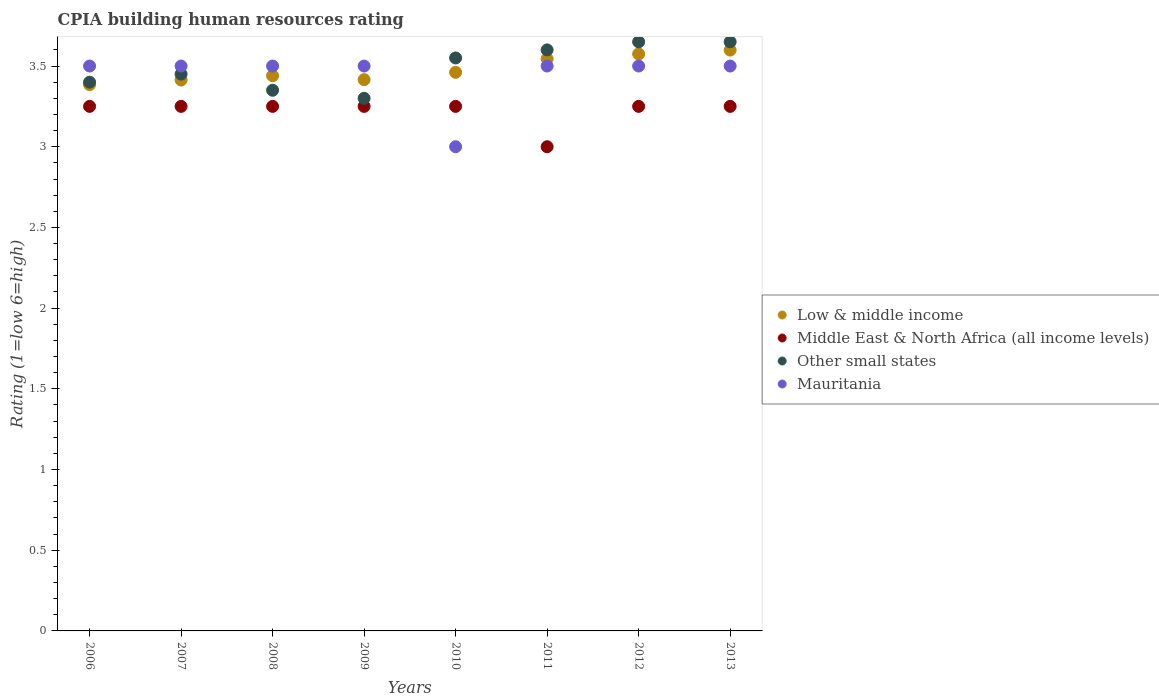What is the CPIA rating in Other small states in 2010?
Your answer should be very brief. 3.55. Across all years, what is the maximum CPIA rating in Low & middle income?
Offer a terse response. 3.6. Across all years, what is the minimum CPIA rating in Low & middle income?
Give a very brief answer. 3.38. In which year was the CPIA rating in Low & middle income minimum?
Provide a succinct answer. 2006. What is the total CPIA rating in Low & middle income in the graph?
Make the answer very short. 27.83. What is the difference between the CPIA rating in Other small states in 2006 and that in 2008?
Offer a very short reply. 0.05. What is the difference between the CPIA rating in Mauritania in 2011 and the CPIA rating in Low & middle income in 2010?
Offer a very short reply. 0.04. What is the average CPIA rating in Other small states per year?
Provide a succinct answer. 3.49. In the year 2006, what is the difference between the CPIA rating in Mauritania and CPIA rating in Low & middle income?
Ensure brevity in your answer.  0.12. In how many years, is the CPIA rating in Middle East & North Africa (all income levels) greater than 1.7?
Offer a very short reply. 8. What is the ratio of the CPIA rating in Mauritania in 2009 to that in 2010?
Your answer should be compact. 1.17. Is the CPIA rating in Low & middle income in 2008 less than that in 2009?
Ensure brevity in your answer.  No. Is the difference between the CPIA rating in Mauritania in 2009 and 2013 greater than the difference between the CPIA rating in Low & middle income in 2009 and 2013?
Your response must be concise. Yes. What is the difference between the highest and the second highest CPIA rating in Middle East & North Africa (all income levels)?
Keep it short and to the point. 0. What is the difference between the highest and the lowest CPIA rating in Other small states?
Ensure brevity in your answer.  0.35. Is the sum of the CPIA rating in Other small states in 2012 and 2013 greater than the maximum CPIA rating in Mauritania across all years?
Your answer should be compact. Yes. Is it the case that in every year, the sum of the CPIA rating in Middle East & North Africa (all income levels) and CPIA rating in Mauritania  is greater than the sum of CPIA rating in Low & middle income and CPIA rating in Other small states?
Offer a terse response. No. Does the CPIA rating in Mauritania monotonically increase over the years?
Make the answer very short. No. Is the CPIA rating in Low & middle income strictly greater than the CPIA rating in Other small states over the years?
Provide a succinct answer. No. How many dotlines are there?
Provide a short and direct response. 4. What is the difference between two consecutive major ticks on the Y-axis?
Your answer should be very brief. 0.5. Does the graph contain any zero values?
Keep it short and to the point. No. How many legend labels are there?
Your response must be concise. 4. How are the legend labels stacked?
Your response must be concise. Vertical. What is the title of the graph?
Your response must be concise. CPIA building human resources rating. What is the Rating (1=low 6=high) in Low & middle income in 2006?
Your response must be concise. 3.38. What is the Rating (1=low 6=high) of Mauritania in 2006?
Your answer should be compact. 3.5. What is the Rating (1=low 6=high) in Low & middle income in 2007?
Give a very brief answer. 3.41. What is the Rating (1=low 6=high) in Other small states in 2007?
Provide a succinct answer. 3.45. What is the Rating (1=low 6=high) of Low & middle income in 2008?
Give a very brief answer. 3.44. What is the Rating (1=low 6=high) of Middle East & North Africa (all income levels) in 2008?
Your response must be concise. 3.25. What is the Rating (1=low 6=high) in Other small states in 2008?
Keep it short and to the point. 3.35. What is the Rating (1=low 6=high) in Mauritania in 2008?
Make the answer very short. 3.5. What is the Rating (1=low 6=high) in Low & middle income in 2009?
Your answer should be compact. 3.42. What is the Rating (1=low 6=high) of Middle East & North Africa (all income levels) in 2009?
Your answer should be compact. 3.25. What is the Rating (1=low 6=high) in Other small states in 2009?
Your answer should be compact. 3.3. What is the Rating (1=low 6=high) in Low & middle income in 2010?
Offer a very short reply. 3.46. What is the Rating (1=low 6=high) in Middle East & North Africa (all income levels) in 2010?
Your answer should be very brief. 3.25. What is the Rating (1=low 6=high) in Other small states in 2010?
Provide a short and direct response. 3.55. What is the Rating (1=low 6=high) in Low & middle income in 2011?
Ensure brevity in your answer.  3.54. What is the Rating (1=low 6=high) in Low & middle income in 2012?
Provide a succinct answer. 3.58. What is the Rating (1=low 6=high) in Other small states in 2012?
Provide a short and direct response. 3.65. What is the Rating (1=low 6=high) in Mauritania in 2012?
Your response must be concise. 3.5. What is the Rating (1=low 6=high) in Low & middle income in 2013?
Offer a very short reply. 3.6. What is the Rating (1=low 6=high) of Other small states in 2013?
Your response must be concise. 3.65. Across all years, what is the maximum Rating (1=low 6=high) of Low & middle income?
Ensure brevity in your answer.  3.6. Across all years, what is the maximum Rating (1=low 6=high) in Other small states?
Give a very brief answer. 3.65. Across all years, what is the maximum Rating (1=low 6=high) of Mauritania?
Give a very brief answer. 3.5. Across all years, what is the minimum Rating (1=low 6=high) of Low & middle income?
Keep it short and to the point. 3.38. Across all years, what is the minimum Rating (1=low 6=high) in Middle East & North Africa (all income levels)?
Make the answer very short. 3. Across all years, what is the minimum Rating (1=low 6=high) of Other small states?
Keep it short and to the point. 3.3. What is the total Rating (1=low 6=high) in Low & middle income in the graph?
Ensure brevity in your answer.  27.83. What is the total Rating (1=low 6=high) in Middle East & North Africa (all income levels) in the graph?
Your answer should be compact. 25.75. What is the total Rating (1=low 6=high) in Other small states in the graph?
Your answer should be very brief. 27.95. What is the difference between the Rating (1=low 6=high) of Low & middle income in 2006 and that in 2007?
Provide a short and direct response. -0.03. What is the difference between the Rating (1=low 6=high) in Middle East & North Africa (all income levels) in 2006 and that in 2007?
Provide a succinct answer. 0. What is the difference between the Rating (1=low 6=high) in Low & middle income in 2006 and that in 2008?
Make the answer very short. -0.06. What is the difference between the Rating (1=low 6=high) in Other small states in 2006 and that in 2008?
Offer a terse response. 0.05. What is the difference between the Rating (1=low 6=high) in Low & middle income in 2006 and that in 2009?
Provide a succinct answer. -0.03. What is the difference between the Rating (1=low 6=high) in Other small states in 2006 and that in 2009?
Offer a terse response. 0.1. What is the difference between the Rating (1=low 6=high) of Mauritania in 2006 and that in 2009?
Your response must be concise. 0. What is the difference between the Rating (1=low 6=high) of Low & middle income in 2006 and that in 2010?
Your response must be concise. -0.08. What is the difference between the Rating (1=low 6=high) in Middle East & North Africa (all income levels) in 2006 and that in 2010?
Keep it short and to the point. 0. What is the difference between the Rating (1=low 6=high) in Mauritania in 2006 and that in 2010?
Give a very brief answer. 0.5. What is the difference between the Rating (1=low 6=high) of Low & middle income in 2006 and that in 2011?
Offer a terse response. -0.16. What is the difference between the Rating (1=low 6=high) in Other small states in 2006 and that in 2011?
Your answer should be compact. -0.2. What is the difference between the Rating (1=low 6=high) in Low & middle income in 2006 and that in 2012?
Offer a terse response. -0.19. What is the difference between the Rating (1=low 6=high) in Other small states in 2006 and that in 2012?
Provide a short and direct response. -0.25. What is the difference between the Rating (1=low 6=high) in Mauritania in 2006 and that in 2012?
Your answer should be compact. 0. What is the difference between the Rating (1=low 6=high) of Low & middle income in 2006 and that in 2013?
Keep it short and to the point. -0.21. What is the difference between the Rating (1=low 6=high) in Other small states in 2006 and that in 2013?
Provide a short and direct response. -0.25. What is the difference between the Rating (1=low 6=high) of Low & middle income in 2007 and that in 2008?
Give a very brief answer. -0.03. What is the difference between the Rating (1=low 6=high) in Low & middle income in 2007 and that in 2009?
Provide a succinct answer. -0. What is the difference between the Rating (1=low 6=high) of Middle East & North Africa (all income levels) in 2007 and that in 2009?
Your response must be concise. 0. What is the difference between the Rating (1=low 6=high) in Low & middle income in 2007 and that in 2010?
Your answer should be compact. -0.05. What is the difference between the Rating (1=low 6=high) in Mauritania in 2007 and that in 2010?
Offer a terse response. 0.5. What is the difference between the Rating (1=low 6=high) of Low & middle income in 2007 and that in 2011?
Offer a terse response. -0.13. What is the difference between the Rating (1=low 6=high) in Middle East & North Africa (all income levels) in 2007 and that in 2011?
Provide a short and direct response. 0.25. What is the difference between the Rating (1=low 6=high) in Other small states in 2007 and that in 2011?
Provide a short and direct response. -0.15. What is the difference between the Rating (1=low 6=high) in Low & middle income in 2007 and that in 2012?
Provide a succinct answer. -0.16. What is the difference between the Rating (1=low 6=high) in Middle East & North Africa (all income levels) in 2007 and that in 2012?
Your answer should be very brief. 0. What is the difference between the Rating (1=low 6=high) in Low & middle income in 2007 and that in 2013?
Ensure brevity in your answer.  -0.19. What is the difference between the Rating (1=low 6=high) of Low & middle income in 2008 and that in 2009?
Offer a terse response. 0.02. What is the difference between the Rating (1=low 6=high) in Middle East & North Africa (all income levels) in 2008 and that in 2009?
Offer a very short reply. 0. What is the difference between the Rating (1=low 6=high) of Other small states in 2008 and that in 2009?
Provide a short and direct response. 0.05. What is the difference between the Rating (1=low 6=high) of Low & middle income in 2008 and that in 2010?
Offer a very short reply. -0.02. What is the difference between the Rating (1=low 6=high) of Middle East & North Africa (all income levels) in 2008 and that in 2010?
Make the answer very short. 0. What is the difference between the Rating (1=low 6=high) in Mauritania in 2008 and that in 2010?
Provide a short and direct response. 0.5. What is the difference between the Rating (1=low 6=high) of Low & middle income in 2008 and that in 2011?
Your response must be concise. -0.1. What is the difference between the Rating (1=low 6=high) in Middle East & North Africa (all income levels) in 2008 and that in 2011?
Ensure brevity in your answer.  0.25. What is the difference between the Rating (1=low 6=high) of Mauritania in 2008 and that in 2011?
Offer a terse response. 0. What is the difference between the Rating (1=low 6=high) of Low & middle income in 2008 and that in 2012?
Provide a succinct answer. -0.14. What is the difference between the Rating (1=low 6=high) in Middle East & North Africa (all income levels) in 2008 and that in 2012?
Your answer should be very brief. 0. What is the difference between the Rating (1=low 6=high) in Other small states in 2008 and that in 2012?
Give a very brief answer. -0.3. What is the difference between the Rating (1=low 6=high) in Mauritania in 2008 and that in 2012?
Give a very brief answer. 0. What is the difference between the Rating (1=low 6=high) in Low & middle income in 2008 and that in 2013?
Your answer should be compact. -0.16. What is the difference between the Rating (1=low 6=high) in Middle East & North Africa (all income levels) in 2008 and that in 2013?
Ensure brevity in your answer.  0. What is the difference between the Rating (1=low 6=high) of Low & middle income in 2009 and that in 2010?
Provide a short and direct response. -0.05. What is the difference between the Rating (1=low 6=high) in Middle East & North Africa (all income levels) in 2009 and that in 2010?
Ensure brevity in your answer.  0. What is the difference between the Rating (1=low 6=high) of Other small states in 2009 and that in 2010?
Keep it short and to the point. -0.25. What is the difference between the Rating (1=low 6=high) of Mauritania in 2009 and that in 2010?
Give a very brief answer. 0.5. What is the difference between the Rating (1=low 6=high) of Low & middle income in 2009 and that in 2011?
Ensure brevity in your answer.  -0.13. What is the difference between the Rating (1=low 6=high) in Middle East & North Africa (all income levels) in 2009 and that in 2011?
Offer a terse response. 0.25. What is the difference between the Rating (1=low 6=high) in Other small states in 2009 and that in 2011?
Your answer should be compact. -0.3. What is the difference between the Rating (1=low 6=high) in Low & middle income in 2009 and that in 2012?
Offer a very short reply. -0.16. What is the difference between the Rating (1=low 6=high) of Middle East & North Africa (all income levels) in 2009 and that in 2012?
Your answer should be very brief. 0. What is the difference between the Rating (1=low 6=high) in Other small states in 2009 and that in 2012?
Provide a short and direct response. -0.35. What is the difference between the Rating (1=low 6=high) in Mauritania in 2009 and that in 2012?
Ensure brevity in your answer.  0. What is the difference between the Rating (1=low 6=high) of Low & middle income in 2009 and that in 2013?
Make the answer very short. -0.18. What is the difference between the Rating (1=low 6=high) of Other small states in 2009 and that in 2013?
Provide a succinct answer. -0.35. What is the difference between the Rating (1=low 6=high) of Low & middle income in 2010 and that in 2011?
Offer a very short reply. -0.08. What is the difference between the Rating (1=low 6=high) in Low & middle income in 2010 and that in 2012?
Your response must be concise. -0.11. What is the difference between the Rating (1=low 6=high) of Middle East & North Africa (all income levels) in 2010 and that in 2012?
Provide a succinct answer. 0. What is the difference between the Rating (1=low 6=high) in Other small states in 2010 and that in 2012?
Provide a succinct answer. -0.1. What is the difference between the Rating (1=low 6=high) in Low & middle income in 2010 and that in 2013?
Your response must be concise. -0.14. What is the difference between the Rating (1=low 6=high) of Other small states in 2010 and that in 2013?
Make the answer very short. -0.1. What is the difference between the Rating (1=low 6=high) of Mauritania in 2010 and that in 2013?
Your response must be concise. -0.5. What is the difference between the Rating (1=low 6=high) in Low & middle income in 2011 and that in 2012?
Offer a terse response. -0.03. What is the difference between the Rating (1=low 6=high) in Other small states in 2011 and that in 2012?
Your answer should be very brief. -0.05. What is the difference between the Rating (1=low 6=high) in Mauritania in 2011 and that in 2012?
Offer a terse response. 0. What is the difference between the Rating (1=low 6=high) in Low & middle income in 2011 and that in 2013?
Keep it short and to the point. -0.05. What is the difference between the Rating (1=low 6=high) in Mauritania in 2011 and that in 2013?
Provide a short and direct response. 0. What is the difference between the Rating (1=low 6=high) of Low & middle income in 2012 and that in 2013?
Provide a succinct answer. -0.02. What is the difference between the Rating (1=low 6=high) in Other small states in 2012 and that in 2013?
Provide a succinct answer. 0. What is the difference between the Rating (1=low 6=high) in Mauritania in 2012 and that in 2013?
Provide a succinct answer. 0. What is the difference between the Rating (1=low 6=high) of Low & middle income in 2006 and the Rating (1=low 6=high) of Middle East & North Africa (all income levels) in 2007?
Keep it short and to the point. 0.13. What is the difference between the Rating (1=low 6=high) in Low & middle income in 2006 and the Rating (1=low 6=high) in Other small states in 2007?
Offer a terse response. -0.07. What is the difference between the Rating (1=low 6=high) of Low & middle income in 2006 and the Rating (1=low 6=high) of Mauritania in 2007?
Offer a very short reply. -0.12. What is the difference between the Rating (1=low 6=high) in Middle East & North Africa (all income levels) in 2006 and the Rating (1=low 6=high) in Other small states in 2007?
Provide a short and direct response. -0.2. What is the difference between the Rating (1=low 6=high) of Low & middle income in 2006 and the Rating (1=low 6=high) of Middle East & North Africa (all income levels) in 2008?
Provide a short and direct response. 0.13. What is the difference between the Rating (1=low 6=high) of Low & middle income in 2006 and the Rating (1=low 6=high) of Other small states in 2008?
Provide a succinct answer. 0.03. What is the difference between the Rating (1=low 6=high) in Low & middle income in 2006 and the Rating (1=low 6=high) in Mauritania in 2008?
Keep it short and to the point. -0.12. What is the difference between the Rating (1=low 6=high) of Middle East & North Africa (all income levels) in 2006 and the Rating (1=low 6=high) of Other small states in 2008?
Ensure brevity in your answer.  -0.1. What is the difference between the Rating (1=low 6=high) in Other small states in 2006 and the Rating (1=low 6=high) in Mauritania in 2008?
Provide a succinct answer. -0.1. What is the difference between the Rating (1=low 6=high) of Low & middle income in 2006 and the Rating (1=low 6=high) of Middle East & North Africa (all income levels) in 2009?
Your answer should be compact. 0.13. What is the difference between the Rating (1=low 6=high) of Low & middle income in 2006 and the Rating (1=low 6=high) of Other small states in 2009?
Give a very brief answer. 0.08. What is the difference between the Rating (1=low 6=high) in Low & middle income in 2006 and the Rating (1=low 6=high) in Mauritania in 2009?
Keep it short and to the point. -0.12. What is the difference between the Rating (1=low 6=high) in Other small states in 2006 and the Rating (1=low 6=high) in Mauritania in 2009?
Your answer should be compact. -0.1. What is the difference between the Rating (1=low 6=high) in Low & middle income in 2006 and the Rating (1=low 6=high) in Middle East & North Africa (all income levels) in 2010?
Offer a very short reply. 0.13. What is the difference between the Rating (1=low 6=high) of Low & middle income in 2006 and the Rating (1=low 6=high) of Other small states in 2010?
Your response must be concise. -0.17. What is the difference between the Rating (1=low 6=high) of Low & middle income in 2006 and the Rating (1=low 6=high) of Mauritania in 2010?
Your answer should be compact. 0.38. What is the difference between the Rating (1=low 6=high) in Middle East & North Africa (all income levels) in 2006 and the Rating (1=low 6=high) in Other small states in 2010?
Keep it short and to the point. -0.3. What is the difference between the Rating (1=low 6=high) in Other small states in 2006 and the Rating (1=low 6=high) in Mauritania in 2010?
Make the answer very short. 0.4. What is the difference between the Rating (1=low 6=high) of Low & middle income in 2006 and the Rating (1=low 6=high) of Middle East & North Africa (all income levels) in 2011?
Provide a short and direct response. 0.38. What is the difference between the Rating (1=low 6=high) in Low & middle income in 2006 and the Rating (1=low 6=high) in Other small states in 2011?
Provide a short and direct response. -0.22. What is the difference between the Rating (1=low 6=high) in Low & middle income in 2006 and the Rating (1=low 6=high) in Mauritania in 2011?
Provide a short and direct response. -0.12. What is the difference between the Rating (1=low 6=high) in Middle East & North Africa (all income levels) in 2006 and the Rating (1=low 6=high) in Other small states in 2011?
Provide a succinct answer. -0.35. What is the difference between the Rating (1=low 6=high) of Middle East & North Africa (all income levels) in 2006 and the Rating (1=low 6=high) of Mauritania in 2011?
Provide a short and direct response. -0.25. What is the difference between the Rating (1=low 6=high) in Low & middle income in 2006 and the Rating (1=low 6=high) in Middle East & North Africa (all income levels) in 2012?
Give a very brief answer. 0.13. What is the difference between the Rating (1=low 6=high) of Low & middle income in 2006 and the Rating (1=low 6=high) of Other small states in 2012?
Your answer should be compact. -0.27. What is the difference between the Rating (1=low 6=high) of Low & middle income in 2006 and the Rating (1=low 6=high) of Mauritania in 2012?
Offer a very short reply. -0.12. What is the difference between the Rating (1=low 6=high) of Other small states in 2006 and the Rating (1=low 6=high) of Mauritania in 2012?
Your response must be concise. -0.1. What is the difference between the Rating (1=low 6=high) of Low & middle income in 2006 and the Rating (1=low 6=high) of Middle East & North Africa (all income levels) in 2013?
Provide a succinct answer. 0.13. What is the difference between the Rating (1=low 6=high) of Low & middle income in 2006 and the Rating (1=low 6=high) of Other small states in 2013?
Ensure brevity in your answer.  -0.27. What is the difference between the Rating (1=low 6=high) of Low & middle income in 2006 and the Rating (1=low 6=high) of Mauritania in 2013?
Keep it short and to the point. -0.12. What is the difference between the Rating (1=low 6=high) in Low & middle income in 2007 and the Rating (1=low 6=high) in Middle East & North Africa (all income levels) in 2008?
Make the answer very short. 0.16. What is the difference between the Rating (1=low 6=high) of Low & middle income in 2007 and the Rating (1=low 6=high) of Other small states in 2008?
Keep it short and to the point. 0.06. What is the difference between the Rating (1=low 6=high) of Low & middle income in 2007 and the Rating (1=low 6=high) of Mauritania in 2008?
Your response must be concise. -0.09. What is the difference between the Rating (1=low 6=high) of Other small states in 2007 and the Rating (1=low 6=high) of Mauritania in 2008?
Provide a short and direct response. -0.05. What is the difference between the Rating (1=low 6=high) in Low & middle income in 2007 and the Rating (1=low 6=high) in Middle East & North Africa (all income levels) in 2009?
Your answer should be compact. 0.16. What is the difference between the Rating (1=low 6=high) of Low & middle income in 2007 and the Rating (1=low 6=high) of Other small states in 2009?
Ensure brevity in your answer.  0.11. What is the difference between the Rating (1=low 6=high) of Low & middle income in 2007 and the Rating (1=low 6=high) of Mauritania in 2009?
Make the answer very short. -0.09. What is the difference between the Rating (1=low 6=high) in Middle East & North Africa (all income levels) in 2007 and the Rating (1=low 6=high) in Other small states in 2009?
Make the answer very short. -0.05. What is the difference between the Rating (1=low 6=high) in Low & middle income in 2007 and the Rating (1=low 6=high) in Middle East & North Africa (all income levels) in 2010?
Provide a short and direct response. 0.16. What is the difference between the Rating (1=low 6=high) of Low & middle income in 2007 and the Rating (1=low 6=high) of Other small states in 2010?
Your answer should be compact. -0.14. What is the difference between the Rating (1=low 6=high) of Low & middle income in 2007 and the Rating (1=low 6=high) of Mauritania in 2010?
Your answer should be compact. 0.41. What is the difference between the Rating (1=low 6=high) in Other small states in 2007 and the Rating (1=low 6=high) in Mauritania in 2010?
Offer a very short reply. 0.45. What is the difference between the Rating (1=low 6=high) in Low & middle income in 2007 and the Rating (1=low 6=high) in Middle East & North Africa (all income levels) in 2011?
Keep it short and to the point. 0.41. What is the difference between the Rating (1=low 6=high) in Low & middle income in 2007 and the Rating (1=low 6=high) in Other small states in 2011?
Make the answer very short. -0.19. What is the difference between the Rating (1=low 6=high) in Low & middle income in 2007 and the Rating (1=low 6=high) in Mauritania in 2011?
Provide a short and direct response. -0.09. What is the difference between the Rating (1=low 6=high) in Middle East & North Africa (all income levels) in 2007 and the Rating (1=low 6=high) in Other small states in 2011?
Offer a very short reply. -0.35. What is the difference between the Rating (1=low 6=high) of Other small states in 2007 and the Rating (1=low 6=high) of Mauritania in 2011?
Provide a short and direct response. -0.05. What is the difference between the Rating (1=low 6=high) of Low & middle income in 2007 and the Rating (1=low 6=high) of Middle East & North Africa (all income levels) in 2012?
Your answer should be very brief. 0.16. What is the difference between the Rating (1=low 6=high) in Low & middle income in 2007 and the Rating (1=low 6=high) in Other small states in 2012?
Ensure brevity in your answer.  -0.24. What is the difference between the Rating (1=low 6=high) of Low & middle income in 2007 and the Rating (1=low 6=high) of Mauritania in 2012?
Your answer should be very brief. -0.09. What is the difference between the Rating (1=low 6=high) in Middle East & North Africa (all income levels) in 2007 and the Rating (1=low 6=high) in Other small states in 2012?
Your response must be concise. -0.4. What is the difference between the Rating (1=low 6=high) in Other small states in 2007 and the Rating (1=low 6=high) in Mauritania in 2012?
Ensure brevity in your answer.  -0.05. What is the difference between the Rating (1=low 6=high) of Low & middle income in 2007 and the Rating (1=low 6=high) of Middle East & North Africa (all income levels) in 2013?
Your response must be concise. 0.16. What is the difference between the Rating (1=low 6=high) of Low & middle income in 2007 and the Rating (1=low 6=high) of Other small states in 2013?
Make the answer very short. -0.24. What is the difference between the Rating (1=low 6=high) of Low & middle income in 2007 and the Rating (1=low 6=high) of Mauritania in 2013?
Your answer should be compact. -0.09. What is the difference between the Rating (1=low 6=high) of Middle East & North Africa (all income levels) in 2007 and the Rating (1=low 6=high) of Other small states in 2013?
Provide a short and direct response. -0.4. What is the difference between the Rating (1=low 6=high) in Middle East & North Africa (all income levels) in 2007 and the Rating (1=low 6=high) in Mauritania in 2013?
Offer a terse response. -0.25. What is the difference between the Rating (1=low 6=high) of Other small states in 2007 and the Rating (1=low 6=high) of Mauritania in 2013?
Provide a short and direct response. -0.05. What is the difference between the Rating (1=low 6=high) of Low & middle income in 2008 and the Rating (1=low 6=high) of Middle East & North Africa (all income levels) in 2009?
Your answer should be compact. 0.19. What is the difference between the Rating (1=low 6=high) in Low & middle income in 2008 and the Rating (1=low 6=high) in Other small states in 2009?
Make the answer very short. 0.14. What is the difference between the Rating (1=low 6=high) in Low & middle income in 2008 and the Rating (1=low 6=high) in Mauritania in 2009?
Keep it short and to the point. -0.06. What is the difference between the Rating (1=low 6=high) in Low & middle income in 2008 and the Rating (1=low 6=high) in Middle East & North Africa (all income levels) in 2010?
Give a very brief answer. 0.19. What is the difference between the Rating (1=low 6=high) of Low & middle income in 2008 and the Rating (1=low 6=high) of Other small states in 2010?
Ensure brevity in your answer.  -0.11. What is the difference between the Rating (1=low 6=high) of Low & middle income in 2008 and the Rating (1=low 6=high) of Mauritania in 2010?
Provide a succinct answer. 0.44. What is the difference between the Rating (1=low 6=high) in Middle East & North Africa (all income levels) in 2008 and the Rating (1=low 6=high) in Other small states in 2010?
Your answer should be very brief. -0.3. What is the difference between the Rating (1=low 6=high) of Other small states in 2008 and the Rating (1=low 6=high) of Mauritania in 2010?
Provide a short and direct response. 0.35. What is the difference between the Rating (1=low 6=high) in Low & middle income in 2008 and the Rating (1=low 6=high) in Middle East & North Africa (all income levels) in 2011?
Provide a succinct answer. 0.44. What is the difference between the Rating (1=low 6=high) in Low & middle income in 2008 and the Rating (1=low 6=high) in Other small states in 2011?
Make the answer very short. -0.16. What is the difference between the Rating (1=low 6=high) in Low & middle income in 2008 and the Rating (1=low 6=high) in Mauritania in 2011?
Your answer should be very brief. -0.06. What is the difference between the Rating (1=low 6=high) of Middle East & North Africa (all income levels) in 2008 and the Rating (1=low 6=high) of Other small states in 2011?
Keep it short and to the point. -0.35. What is the difference between the Rating (1=low 6=high) in Other small states in 2008 and the Rating (1=low 6=high) in Mauritania in 2011?
Ensure brevity in your answer.  -0.15. What is the difference between the Rating (1=low 6=high) in Low & middle income in 2008 and the Rating (1=low 6=high) in Middle East & North Africa (all income levels) in 2012?
Your response must be concise. 0.19. What is the difference between the Rating (1=low 6=high) in Low & middle income in 2008 and the Rating (1=low 6=high) in Other small states in 2012?
Keep it short and to the point. -0.21. What is the difference between the Rating (1=low 6=high) in Low & middle income in 2008 and the Rating (1=low 6=high) in Mauritania in 2012?
Ensure brevity in your answer.  -0.06. What is the difference between the Rating (1=low 6=high) of Middle East & North Africa (all income levels) in 2008 and the Rating (1=low 6=high) of Mauritania in 2012?
Provide a short and direct response. -0.25. What is the difference between the Rating (1=low 6=high) of Other small states in 2008 and the Rating (1=low 6=high) of Mauritania in 2012?
Offer a terse response. -0.15. What is the difference between the Rating (1=low 6=high) in Low & middle income in 2008 and the Rating (1=low 6=high) in Middle East & North Africa (all income levels) in 2013?
Offer a very short reply. 0.19. What is the difference between the Rating (1=low 6=high) of Low & middle income in 2008 and the Rating (1=low 6=high) of Other small states in 2013?
Your response must be concise. -0.21. What is the difference between the Rating (1=low 6=high) in Low & middle income in 2008 and the Rating (1=low 6=high) in Mauritania in 2013?
Provide a succinct answer. -0.06. What is the difference between the Rating (1=low 6=high) in Middle East & North Africa (all income levels) in 2008 and the Rating (1=low 6=high) in Other small states in 2013?
Offer a terse response. -0.4. What is the difference between the Rating (1=low 6=high) of Middle East & North Africa (all income levels) in 2008 and the Rating (1=low 6=high) of Mauritania in 2013?
Make the answer very short. -0.25. What is the difference between the Rating (1=low 6=high) of Low & middle income in 2009 and the Rating (1=low 6=high) of Middle East & North Africa (all income levels) in 2010?
Offer a terse response. 0.17. What is the difference between the Rating (1=low 6=high) in Low & middle income in 2009 and the Rating (1=low 6=high) in Other small states in 2010?
Keep it short and to the point. -0.13. What is the difference between the Rating (1=low 6=high) in Low & middle income in 2009 and the Rating (1=low 6=high) in Mauritania in 2010?
Your answer should be very brief. 0.42. What is the difference between the Rating (1=low 6=high) of Low & middle income in 2009 and the Rating (1=low 6=high) of Middle East & North Africa (all income levels) in 2011?
Your answer should be very brief. 0.42. What is the difference between the Rating (1=low 6=high) of Low & middle income in 2009 and the Rating (1=low 6=high) of Other small states in 2011?
Keep it short and to the point. -0.18. What is the difference between the Rating (1=low 6=high) in Low & middle income in 2009 and the Rating (1=low 6=high) in Mauritania in 2011?
Ensure brevity in your answer.  -0.08. What is the difference between the Rating (1=low 6=high) of Middle East & North Africa (all income levels) in 2009 and the Rating (1=low 6=high) of Other small states in 2011?
Keep it short and to the point. -0.35. What is the difference between the Rating (1=low 6=high) in Middle East & North Africa (all income levels) in 2009 and the Rating (1=low 6=high) in Mauritania in 2011?
Offer a very short reply. -0.25. What is the difference between the Rating (1=low 6=high) of Low & middle income in 2009 and the Rating (1=low 6=high) of Middle East & North Africa (all income levels) in 2012?
Your answer should be very brief. 0.17. What is the difference between the Rating (1=low 6=high) in Low & middle income in 2009 and the Rating (1=low 6=high) in Other small states in 2012?
Give a very brief answer. -0.23. What is the difference between the Rating (1=low 6=high) in Low & middle income in 2009 and the Rating (1=low 6=high) in Mauritania in 2012?
Your answer should be compact. -0.08. What is the difference between the Rating (1=low 6=high) of Middle East & North Africa (all income levels) in 2009 and the Rating (1=low 6=high) of Other small states in 2012?
Your answer should be very brief. -0.4. What is the difference between the Rating (1=low 6=high) of Middle East & North Africa (all income levels) in 2009 and the Rating (1=low 6=high) of Mauritania in 2012?
Provide a succinct answer. -0.25. What is the difference between the Rating (1=low 6=high) of Low & middle income in 2009 and the Rating (1=low 6=high) of Middle East & North Africa (all income levels) in 2013?
Keep it short and to the point. 0.17. What is the difference between the Rating (1=low 6=high) of Low & middle income in 2009 and the Rating (1=low 6=high) of Other small states in 2013?
Your answer should be compact. -0.23. What is the difference between the Rating (1=low 6=high) in Low & middle income in 2009 and the Rating (1=low 6=high) in Mauritania in 2013?
Your answer should be compact. -0.08. What is the difference between the Rating (1=low 6=high) of Middle East & North Africa (all income levels) in 2009 and the Rating (1=low 6=high) of Other small states in 2013?
Your answer should be very brief. -0.4. What is the difference between the Rating (1=low 6=high) in Middle East & North Africa (all income levels) in 2009 and the Rating (1=low 6=high) in Mauritania in 2013?
Your answer should be very brief. -0.25. What is the difference between the Rating (1=low 6=high) in Low & middle income in 2010 and the Rating (1=low 6=high) in Middle East & North Africa (all income levels) in 2011?
Your answer should be compact. 0.46. What is the difference between the Rating (1=low 6=high) in Low & middle income in 2010 and the Rating (1=low 6=high) in Other small states in 2011?
Offer a very short reply. -0.14. What is the difference between the Rating (1=low 6=high) in Low & middle income in 2010 and the Rating (1=low 6=high) in Mauritania in 2011?
Make the answer very short. -0.04. What is the difference between the Rating (1=low 6=high) in Middle East & North Africa (all income levels) in 2010 and the Rating (1=low 6=high) in Other small states in 2011?
Offer a terse response. -0.35. What is the difference between the Rating (1=low 6=high) in Middle East & North Africa (all income levels) in 2010 and the Rating (1=low 6=high) in Mauritania in 2011?
Provide a short and direct response. -0.25. What is the difference between the Rating (1=low 6=high) in Low & middle income in 2010 and the Rating (1=low 6=high) in Middle East & North Africa (all income levels) in 2012?
Your answer should be compact. 0.21. What is the difference between the Rating (1=low 6=high) of Low & middle income in 2010 and the Rating (1=low 6=high) of Other small states in 2012?
Give a very brief answer. -0.19. What is the difference between the Rating (1=low 6=high) of Low & middle income in 2010 and the Rating (1=low 6=high) of Mauritania in 2012?
Provide a succinct answer. -0.04. What is the difference between the Rating (1=low 6=high) in Middle East & North Africa (all income levels) in 2010 and the Rating (1=low 6=high) in Other small states in 2012?
Offer a very short reply. -0.4. What is the difference between the Rating (1=low 6=high) in Middle East & North Africa (all income levels) in 2010 and the Rating (1=low 6=high) in Mauritania in 2012?
Offer a very short reply. -0.25. What is the difference between the Rating (1=low 6=high) in Other small states in 2010 and the Rating (1=low 6=high) in Mauritania in 2012?
Offer a terse response. 0.05. What is the difference between the Rating (1=low 6=high) in Low & middle income in 2010 and the Rating (1=low 6=high) in Middle East & North Africa (all income levels) in 2013?
Your answer should be very brief. 0.21. What is the difference between the Rating (1=low 6=high) in Low & middle income in 2010 and the Rating (1=low 6=high) in Other small states in 2013?
Offer a terse response. -0.19. What is the difference between the Rating (1=low 6=high) of Low & middle income in 2010 and the Rating (1=low 6=high) of Mauritania in 2013?
Make the answer very short. -0.04. What is the difference between the Rating (1=low 6=high) in Low & middle income in 2011 and the Rating (1=low 6=high) in Middle East & North Africa (all income levels) in 2012?
Offer a very short reply. 0.29. What is the difference between the Rating (1=low 6=high) in Low & middle income in 2011 and the Rating (1=low 6=high) in Other small states in 2012?
Offer a terse response. -0.11. What is the difference between the Rating (1=low 6=high) of Low & middle income in 2011 and the Rating (1=low 6=high) of Mauritania in 2012?
Offer a very short reply. 0.04. What is the difference between the Rating (1=low 6=high) in Middle East & North Africa (all income levels) in 2011 and the Rating (1=low 6=high) in Other small states in 2012?
Provide a short and direct response. -0.65. What is the difference between the Rating (1=low 6=high) of Middle East & North Africa (all income levels) in 2011 and the Rating (1=low 6=high) of Mauritania in 2012?
Offer a very short reply. -0.5. What is the difference between the Rating (1=low 6=high) in Low & middle income in 2011 and the Rating (1=low 6=high) in Middle East & North Africa (all income levels) in 2013?
Offer a terse response. 0.29. What is the difference between the Rating (1=low 6=high) of Low & middle income in 2011 and the Rating (1=low 6=high) of Other small states in 2013?
Give a very brief answer. -0.11. What is the difference between the Rating (1=low 6=high) in Low & middle income in 2011 and the Rating (1=low 6=high) in Mauritania in 2013?
Offer a very short reply. 0.04. What is the difference between the Rating (1=low 6=high) in Middle East & North Africa (all income levels) in 2011 and the Rating (1=low 6=high) in Other small states in 2013?
Your answer should be compact. -0.65. What is the difference between the Rating (1=low 6=high) of Middle East & North Africa (all income levels) in 2011 and the Rating (1=low 6=high) of Mauritania in 2013?
Give a very brief answer. -0.5. What is the difference between the Rating (1=low 6=high) of Low & middle income in 2012 and the Rating (1=low 6=high) of Middle East & North Africa (all income levels) in 2013?
Offer a terse response. 0.33. What is the difference between the Rating (1=low 6=high) in Low & middle income in 2012 and the Rating (1=low 6=high) in Other small states in 2013?
Provide a short and direct response. -0.07. What is the difference between the Rating (1=low 6=high) of Low & middle income in 2012 and the Rating (1=low 6=high) of Mauritania in 2013?
Your response must be concise. 0.07. What is the difference between the Rating (1=low 6=high) of Middle East & North Africa (all income levels) in 2012 and the Rating (1=low 6=high) of Other small states in 2013?
Your answer should be very brief. -0.4. What is the difference between the Rating (1=low 6=high) of Middle East & North Africa (all income levels) in 2012 and the Rating (1=low 6=high) of Mauritania in 2013?
Offer a terse response. -0.25. What is the average Rating (1=low 6=high) in Low & middle income per year?
Provide a succinct answer. 3.48. What is the average Rating (1=low 6=high) in Middle East & North Africa (all income levels) per year?
Your answer should be compact. 3.22. What is the average Rating (1=low 6=high) in Other small states per year?
Provide a succinct answer. 3.49. What is the average Rating (1=low 6=high) of Mauritania per year?
Give a very brief answer. 3.44. In the year 2006, what is the difference between the Rating (1=low 6=high) of Low & middle income and Rating (1=low 6=high) of Middle East & North Africa (all income levels)?
Give a very brief answer. 0.13. In the year 2006, what is the difference between the Rating (1=low 6=high) of Low & middle income and Rating (1=low 6=high) of Other small states?
Your answer should be very brief. -0.02. In the year 2006, what is the difference between the Rating (1=low 6=high) in Low & middle income and Rating (1=low 6=high) in Mauritania?
Give a very brief answer. -0.12. In the year 2006, what is the difference between the Rating (1=low 6=high) of Middle East & North Africa (all income levels) and Rating (1=low 6=high) of Mauritania?
Your answer should be compact. -0.25. In the year 2006, what is the difference between the Rating (1=low 6=high) of Other small states and Rating (1=low 6=high) of Mauritania?
Offer a very short reply. -0.1. In the year 2007, what is the difference between the Rating (1=low 6=high) of Low & middle income and Rating (1=low 6=high) of Middle East & North Africa (all income levels)?
Make the answer very short. 0.16. In the year 2007, what is the difference between the Rating (1=low 6=high) in Low & middle income and Rating (1=low 6=high) in Other small states?
Provide a succinct answer. -0.04. In the year 2007, what is the difference between the Rating (1=low 6=high) of Low & middle income and Rating (1=low 6=high) of Mauritania?
Your response must be concise. -0.09. In the year 2007, what is the difference between the Rating (1=low 6=high) of Middle East & North Africa (all income levels) and Rating (1=low 6=high) of Other small states?
Your response must be concise. -0.2. In the year 2008, what is the difference between the Rating (1=low 6=high) in Low & middle income and Rating (1=low 6=high) in Middle East & North Africa (all income levels)?
Give a very brief answer. 0.19. In the year 2008, what is the difference between the Rating (1=low 6=high) of Low & middle income and Rating (1=low 6=high) of Other small states?
Your response must be concise. 0.09. In the year 2008, what is the difference between the Rating (1=low 6=high) in Low & middle income and Rating (1=low 6=high) in Mauritania?
Make the answer very short. -0.06. In the year 2008, what is the difference between the Rating (1=low 6=high) of Middle East & North Africa (all income levels) and Rating (1=low 6=high) of Other small states?
Your answer should be very brief. -0.1. In the year 2008, what is the difference between the Rating (1=low 6=high) of Middle East & North Africa (all income levels) and Rating (1=low 6=high) of Mauritania?
Make the answer very short. -0.25. In the year 2009, what is the difference between the Rating (1=low 6=high) in Low & middle income and Rating (1=low 6=high) in Middle East & North Africa (all income levels)?
Ensure brevity in your answer.  0.17. In the year 2009, what is the difference between the Rating (1=low 6=high) in Low & middle income and Rating (1=low 6=high) in Other small states?
Make the answer very short. 0.12. In the year 2009, what is the difference between the Rating (1=low 6=high) in Low & middle income and Rating (1=low 6=high) in Mauritania?
Your answer should be compact. -0.08. In the year 2010, what is the difference between the Rating (1=low 6=high) in Low & middle income and Rating (1=low 6=high) in Middle East & North Africa (all income levels)?
Your answer should be very brief. 0.21. In the year 2010, what is the difference between the Rating (1=low 6=high) in Low & middle income and Rating (1=low 6=high) in Other small states?
Keep it short and to the point. -0.09. In the year 2010, what is the difference between the Rating (1=low 6=high) in Low & middle income and Rating (1=low 6=high) in Mauritania?
Your answer should be compact. 0.46. In the year 2010, what is the difference between the Rating (1=low 6=high) in Middle East & North Africa (all income levels) and Rating (1=low 6=high) in Other small states?
Offer a very short reply. -0.3. In the year 2010, what is the difference between the Rating (1=low 6=high) of Other small states and Rating (1=low 6=high) of Mauritania?
Your response must be concise. 0.55. In the year 2011, what is the difference between the Rating (1=low 6=high) in Low & middle income and Rating (1=low 6=high) in Middle East & North Africa (all income levels)?
Your answer should be compact. 0.54. In the year 2011, what is the difference between the Rating (1=low 6=high) of Low & middle income and Rating (1=low 6=high) of Other small states?
Make the answer very short. -0.06. In the year 2011, what is the difference between the Rating (1=low 6=high) in Low & middle income and Rating (1=low 6=high) in Mauritania?
Ensure brevity in your answer.  0.04. In the year 2011, what is the difference between the Rating (1=low 6=high) of Middle East & North Africa (all income levels) and Rating (1=low 6=high) of Other small states?
Provide a short and direct response. -0.6. In the year 2012, what is the difference between the Rating (1=low 6=high) of Low & middle income and Rating (1=low 6=high) of Middle East & North Africa (all income levels)?
Offer a terse response. 0.33. In the year 2012, what is the difference between the Rating (1=low 6=high) of Low & middle income and Rating (1=low 6=high) of Other small states?
Your answer should be compact. -0.07. In the year 2012, what is the difference between the Rating (1=low 6=high) in Low & middle income and Rating (1=low 6=high) in Mauritania?
Ensure brevity in your answer.  0.07. In the year 2012, what is the difference between the Rating (1=low 6=high) of Middle East & North Africa (all income levels) and Rating (1=low 6=high) of Mauritania?
Your answer should be very brief. -0.25. In the year 2013, what is the difference between the Rating (1=low 6=high) in Low & middle income and Rating (1=low 6=high) in Middle East & North Africa (all income levels)?
Offer a very short reply. 0.35. In the year 2013, what is the difference between the Rating (1=low 6=high) in Low & middle income and Rating (1=low 6=high) in Other small states?
Ensure brevity in your answer.  -0.05. In the year 2013, what is the difference between the Rating (1=low 6=high) of Low & middle income and Rating (1=low 6=high) of Mauritania?
Your answer should be compact. 0.1. What is the ratio of the Rating (1=low 6=high) in Low & middle income in 2006 to that in 2007?
Your answer should be compact. 0.99. What is the ratio of the Rating (1=low 6=high) of Middle East & North Africa (all income levels) in 2006 to that in 2007?
Ensure brevity in your answer.  1. What is the ratio of the Rating (1=low 6=high) of Other small states in 2006 to that in 2007?
Keep it short and to the point. 0.99. What is the ratio of the Rating (1=low 6=high) of Low & middle income in 2006 to that in 2008?
Give a very brief answer. 0.98. What is the ratio of the Rating (1=low 6=high) of Middle East & North Africa (all income levels) in 2006 to that in 2008?
Ensure brevity in your answer.  1. What is the ratio of the Rating (1=low 6=high) of Other small states in 2006 to that in 2008?
Your answer should be very brief. 1.01. What is the ratio of the Rating (1=low 6=high) in Mauritania in 2006 to that in 2008?
Provide a succinct answer. 1. What is the ratio of the Rating (1=low 6=high) in Low & middle income in 2006 to that in 2009?
Your answer should be compact. 0.99. What is the ratio of the Rating (1=low 6=high) in Middle East & North Africa (all income levels) in 2006 to that in 2009?
Your response must be concise. 1. What is the ratio of the Rating (1=low 6=high) of Other small states in 2006 to that in 2009?
Keep it short and to the point. 1.03. What is the ratio of the Rating (1=low 6=high) in Low & middle income in 2006 to that in 2010?
Give a very brief answer. 0.98. What is the ratio of the Rating (1=low 6=high) of Middle East & North Africa (all income levels) in 2006 to that in 2010?
Make the answer very short. 1. What is the ratio of the Rating (1=low 6=high) of Other small states in 2006 to that in 2010?
Ensure brevity in your answer.  0.96. What is the ratio of the Rating (1=low 6=high) in Mauritania in 2006 to that in 2010?
Your response must be concise. 1.17. What is the ratio of the Rating (1=low 6=high) in Low & middle income in 2006 to that in 2011?
Give a very brief answer. 0.95. What is the ratio of the Rating (1=low 6=high) in Low & middle income in 2006 to that in 2012?
Provide a short and direct response. 0.95. What is the ratio of the Rating (1=low 6=high) of Middle East & North Africa (all income levels) in 2006 to that in 2012?
Your answer should be compact. 1. What is the ratio of the Rating (1=low 6=high) in Other small states in 2006 to that in 2012?
Provide a short and direct response. 0.93. What is the ratio of the Rating (1=low 6=high) of Low & middle income in 2006 to that in 2013?
Provide a short and direct response. 0.94. What is the ratio of the Rating (1=low 6=high) in Other small states in 2006 to that in 2013?
Provide a short and direct response. 0.93. What is the ratio of the Rating (1=low 6=high) in Mauritania in 2006 to that in 2013?
Your answer should be very brief. 1. What is the ratio of the Rating (1=low 6=high) in Low & middle income in 2007 to that in 2008?
Ensure brevity in your answer.  0.99. What is the ratio of the Rating (1=low 6=high) in Other small states in 2007 to that in 2008?
Offer a terse response. 1.03. What is the ratio of the Rating (1=low 6=high) in Middle East & North Africa (all income levels) in 2007 to that in 2009?
Ensure brevity in your answer.  1. What is the ratio of the Rating (1=low 6=high) in Other small states in 2007 to that in 2009?
Provide a short and direct response. 1.05. What is the ratio of the Rating (1=low 6=high) of Low & middle income in 2007 to that in 2010?
Offer a terse response. 0.99. What is the ratio of the Rating (1=low 6=high) of Middle East & North Africa (all income levels) in 2007 to that in 2010?
Ensure brevity in your answer.  1. What is the ratio of the Rating (1=low 6=high) of Other small states in 2007 to that in 2010?
Offer a terse response. 0.97. What is the ratio of the Rating (1=low 6=high) of Low & middle income in 2007 to that in 2011?
Your response must be concise. 0.96. What is the ratio of the Rating (1=low 6=high) of Middle East & North Africa (all income levels) in 2007 to that in 2011?
Make the answer very short. 1.08. What is the ratio of the Rating (1=low 6=high) of Other small states in 2007 to that in 2011?
Your response must be concise. 0.96. What is the ratio of the Rating (1=low 6=high) of Mauritania in 2007 to that in 2011?
Ensure brevity in your answer.  1. What is the ratio of the Rating (1=low 6=high) in Low & middle income in 2007 to that in 2012?
Your answer should be compact. 0.95. What is the ratio of the Rating (1=low 6=high) in Other small states in 2007 to that in 2012?
Keep it short and to the point. 0.95. What is the ratio of the Rating (1=low 6=high) in Low & middle income in 2007 to that in 2013?
Ensure brevity in your answer.  0.95. What is the ratio of the Rating (1=low 6=high) of Other small states in 2007 to that in 2013?
Provide a short and direct response. 0.95. What is the ratio of the Rating (1=low 6=high) in Low & middle income in 2008 to that in 2009?
Your answer should be very brief. 1.01. What is the ratio of the Rating (1=low 6=high) in Other small states in 2008 to that in 2009?
Give a very brief answer. 1.02. What is the ratio of the Rating (1=low 6=high) in Mauritania in 2008 to that in 2009?
Ensure brevity in your answer.  1. What is the ratio of the Rating (1=low 6=high) in Other small states in 2008 to that in 2010?
Give a very brief answer. 0.94. What is the ratio of the Rating (1=low 6=high) of Low & middle income in 2008 to that in 2011?
Provide a succinct answer. 0.97. What is the ratio of the Rating (1=low 6=high) of Other small states in 2008 to that in 2011?
Your response must be concise. 0.93. What is the ratio of the Rating (1=low 6=high) in Low & middle income in 2008 to that in 2012?
Keep it short and to the point. 0.96. What is the ratio of the Rating (1=low 6=high) in Other small states in 2008 to that in 2012?
Offer a very short reply. 0.92. What is the ratio of the Rating (1=low 6=high) of Low & middle income in 2008 to that in 2013?
Your answer should be very brief. 0.96. What is the ratio of the Rating (1=low 6=high) in Other small states in 2008 to that in 2013?
Ensure brevity in your answer.  0.92. What is the ratio of the Rating (1=low 6=high) in Low & middle income in 2009 to that in 2010?
Provide a short and direct response. 0.99. What is the ratio of the Rating (1=low 6=high) in Middle East & North Africa (all income levels) in 2009 to that in 2010?
Offer a very short reply. 1. What is the ratio of the Rating (1=low 6=high) of Other small states in 2009 to that in 2010?
Your answer should be compact. 0.93. What is the ratio of the Rating (1=low 6=high) in Low & middle income in 2009 to that in 2011?
Provide a succinct answer. 0.96. What is the ratio of the Rating (1=low 6=high) of Other small states in 2009 to that in 2011?
Give a very brief answer. 0.92. What is the ratio of the Rating (1=low 6=high) of Mauritania in 2009 to that in 2011?
Provide a succinct answer. 1. What is the ratio of the Rating (1=low 6=high) in Low & middle income in 2009 to that in 2012?
Keep it short and to the point. 0.96. What is the ratio of the Rating (1=low 6=high) of Middle East & North Africa (all income levels) in 2009 to that in 2012?
Make the answer very short. 1. What is the ratio of the Rating (1=low 6=high) in Other small states in 2009 to that in 2012?
Provide a short and direct response. 0.9. What is the ratio of the Rating (1=low 6=high) of Mauritania in 2009 to that in 2012?
Your answer should be compact. 1. What is the ratio of the Rating (1=low 6=high) in Low & middle income in 2009 to that in 2013?
Give a very brief answer. 0.95. What is the ratio of the Rating (1=low 6=high) in Other small states in 2009 to that in 2013?
Give a very brief answer. 0.9. What is the ratio of the Rating (1=low 6=high) of Low & middle income in 2010 to that in 2011?
Provide a short and direct response. 0.98. What is the ratio of the Rating (1=low 6=high) in Other small states in 2010 to that in 2011?
Your answer should be very brief. 0.99. What is the ratio of the Rating (1=low 6=high) in Low & middle income in 2010 to that in 2012?
Give a very brief answer. 0.97. What is the ratio of the Rating (1=low 6=high) of Other small states in 2010 to that in 2012?
Your answer should be compact. 0.97. What is the ratio of the Rating (1=low 6=high) of Mauritania in 2010 to that in 2012?
Give a very brief answer. 0.86. What is the ratio of the Rating (1=low 6=high) of Low & middle income in 2010 to that in 2013?
Provide a succinct answer. 0.96. What is the ratio of the Rating (1=low 6=high) of Middle East & North Africa (all income levels) in 2010 to that in 2013?
Your response must be concise. 1. What is the ratio of the Rating (1=low 6=high) of Other small states in 2010 to that in 2013?
Make the answer very short. 0.97. What is the ratio of the Rating (1=low 6=high) in Middle East & North Africa (all income levels) in 2011 to that in 2012?
Make the answer very short. 0.92. What is the ratio of the Rating (1=low 6=high) of Other small states in 2011 to that in 2012?
Make the answer very short. 0.99. What is the ratio of the Rating (1=low 6=high) of Mauritania in 2011 to that in 2012?
Provide a short and direct response. 1. What is the ratio of the Rating (1=low 6=high) in Low & middle income in 2011 to that in 2013?
Ensure brevity in your answer.  0.98. What is the ratio of the Rating (1=low 6=high) in Middle East & North Africa (all income levels) in 2011 to that in 2013?
Ensure brevity in your answer.  0.92. What is the ratio of the Rating (1=low 6=high) of Other small states in 2011 to that in 2013?
Your response must be concise. 0.99. What is the ratio of the Rating (1=low 6=high) of Mauritania in 2011 to that in 2013?
Provide a succinct answer. 1. What is the difference between the highest and the second highest Rating (1=low 6=high) of Low & middle income?
Your answer should be very brief. 0.02. What is the difference between the highest and the second highest Rating (1=low 6=high) in Middle East & North Africa (all income levels)?
Ensure brevity in your answer.  0. What is the difference between the highest and the lowest Rating (1=low 6=high) in Low & middle income?
Offer a very short reply. 0.21. What is the difference between the highest and the lowest Rating (1=low 6=high) in Middle East & North Africa (all income levels)?
Provide a short and direct response. 0.25. What is the difference between the highest and the lowest Rating (1=low 6=high) in Mauritania?
Make the answer very short. 0.5. 